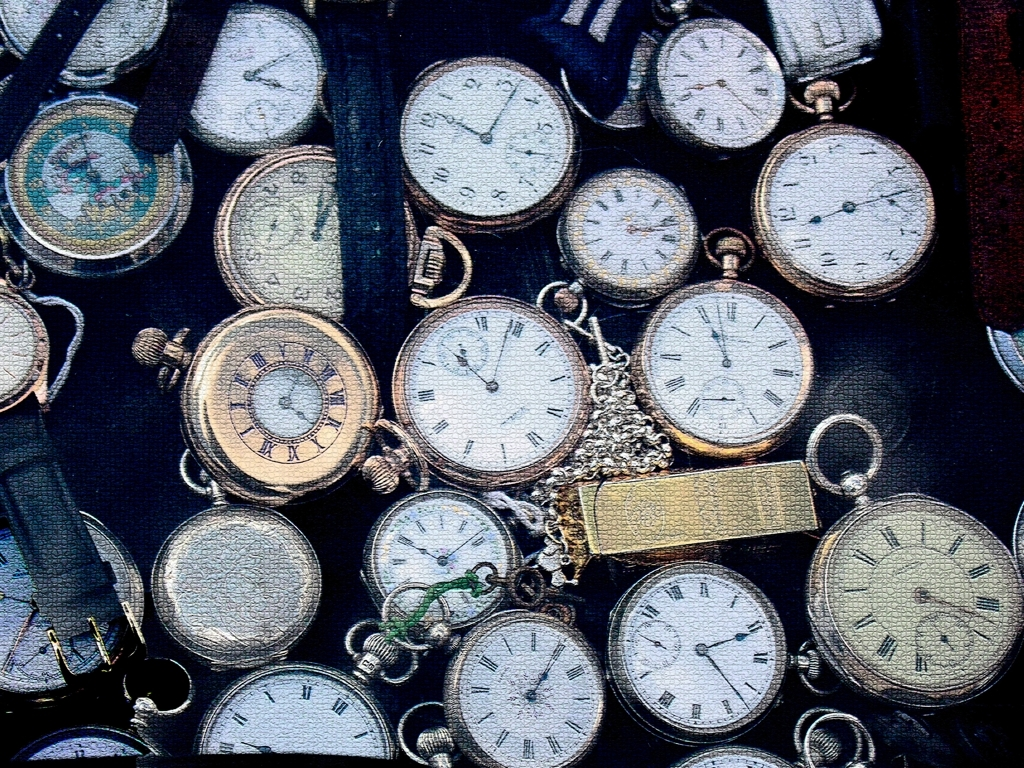Does the image have low clarity? The image is clear and shows distinct details, showcasing a collection of pocket watches with various designs, face types, and chain attachments, all visible with good resolution. 